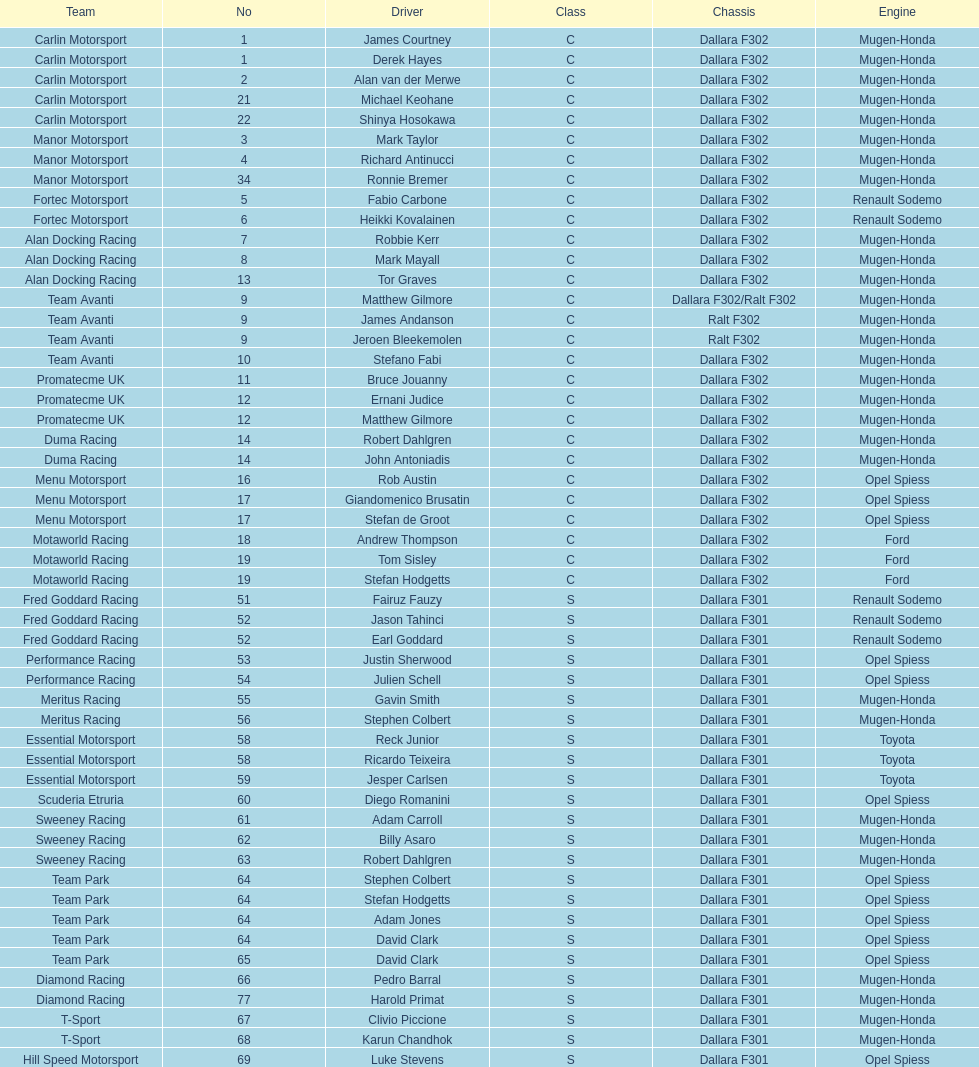The two drivers on t-sport are clivio piccione and what other driver? Karun Chandhok. 